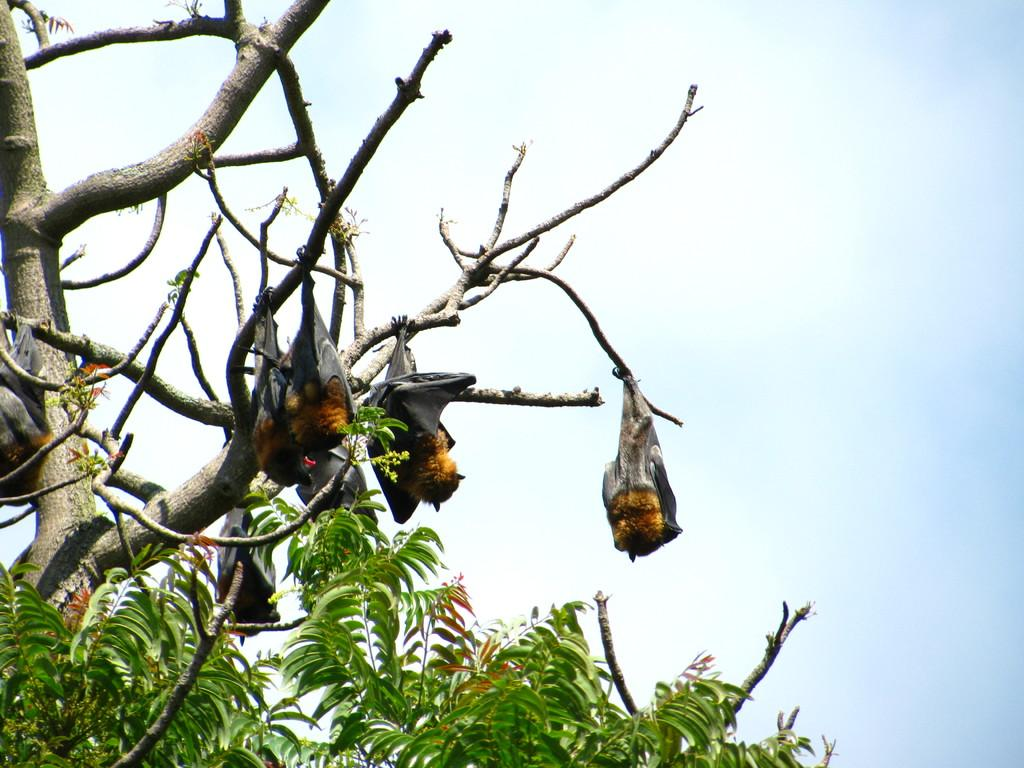What animals can be seen on the tree in the image? There are bats on the tree in the image. What part of the natural environment is visible in the background of the image? Sky is visible in the background of the image. How many steps are visible in the image? There are no steps present in the image. What type of box can be seen in the image? There is no box present in the image. 